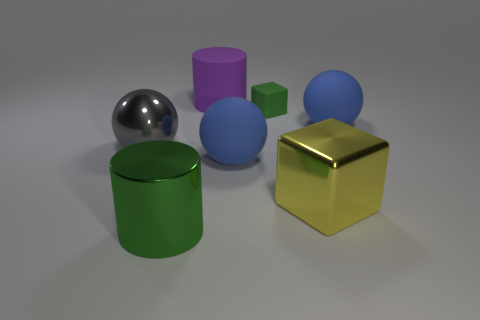Add 2 big red metallic things. How many objects exist? 9 Subtract all cylinders. How many objects are left? 5 Subtract 0 green balls. How many objects are left? 7 Subtract all big metal spheres. Subtract all green objects. How many objects are left? 4 Add 1 big gray shiny things. How many big gray shiny things are left? 2 Add 7 small blue shiny objects. How many small blue shiny objects exist? 7 